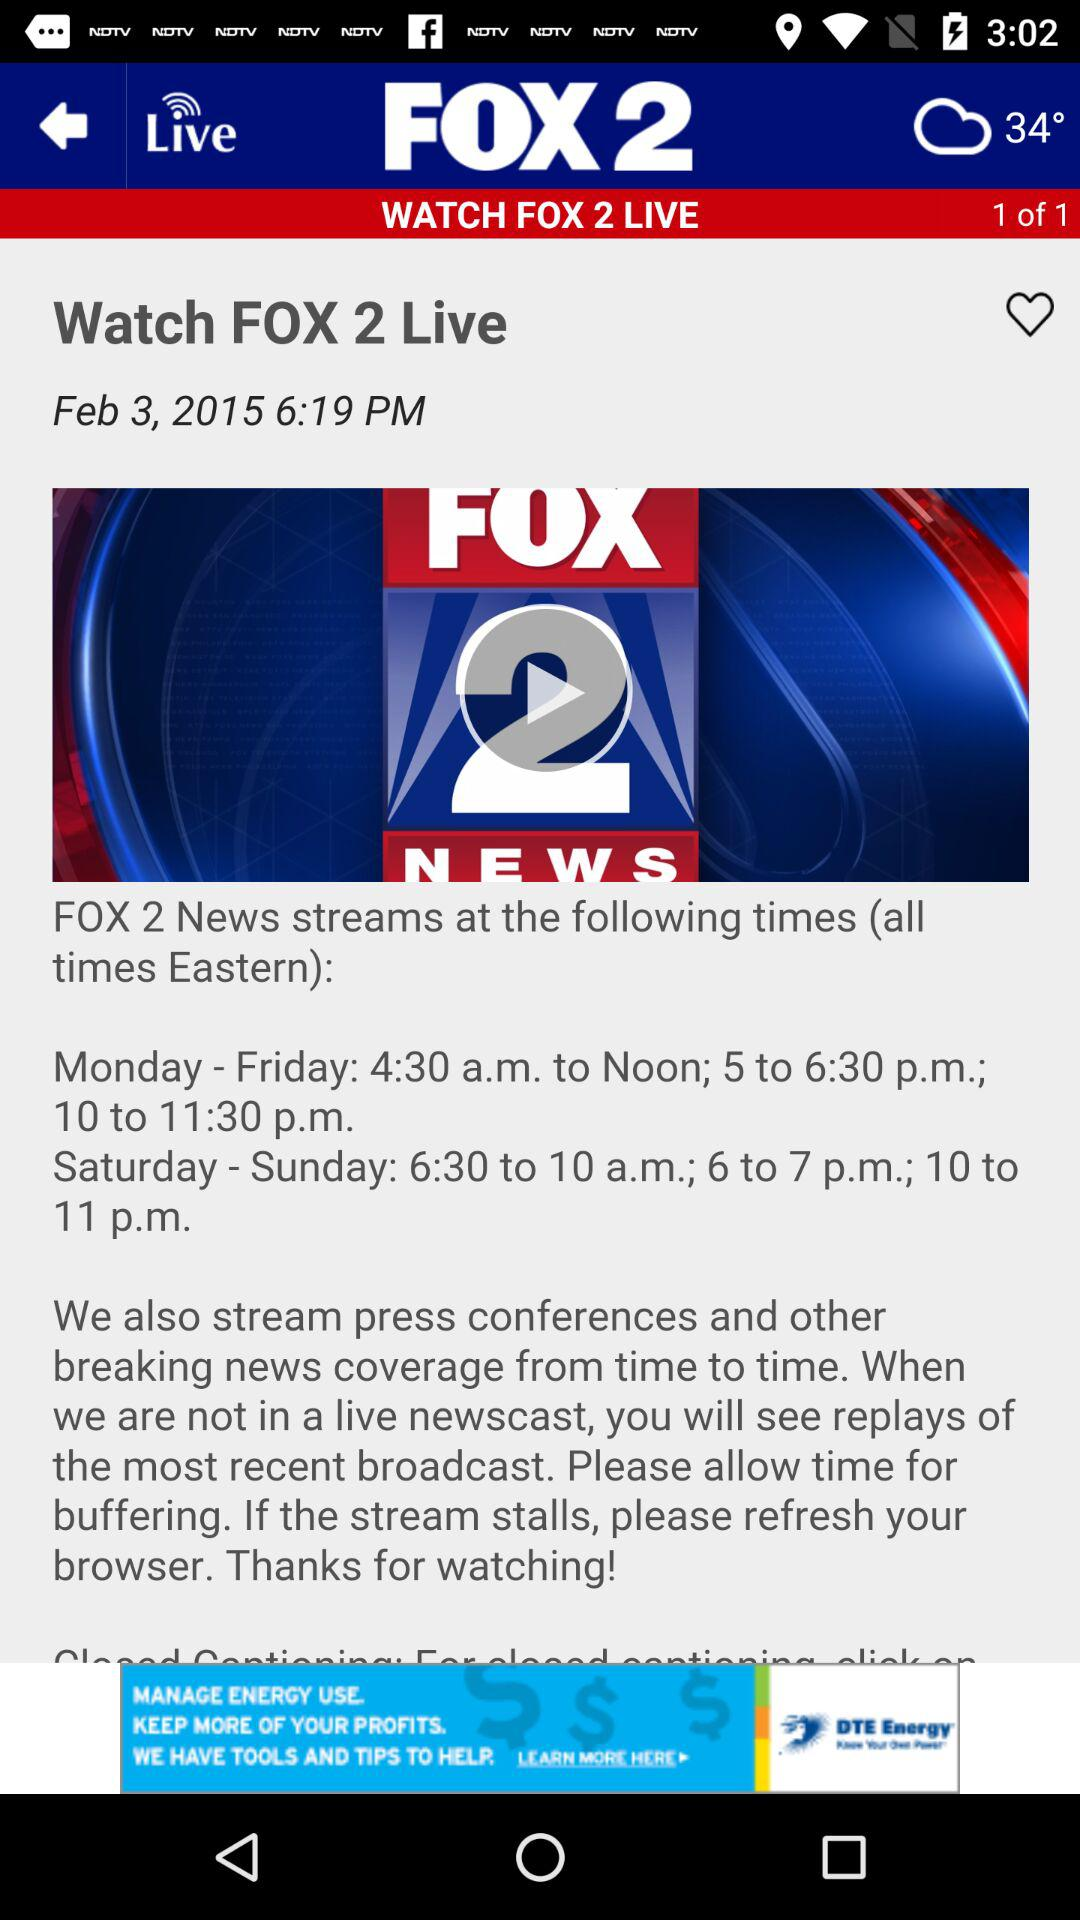What is the weather and temperature? The weather is cloudy and the temperature is 34°. 